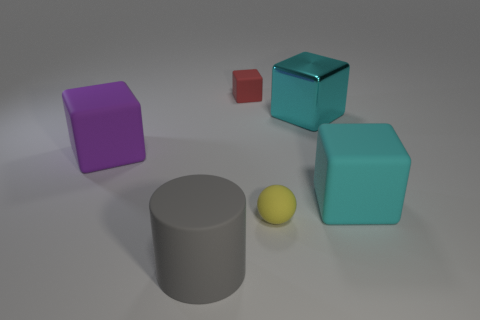Subtract 1 cubes. How many cubes are left? 3 Add 2 big red matte cubes. How many objects exist? 8 Subtract all balls. How many objects are left? 5 Add 2 red blocks. How many red blocks exist? 3 Subtract 1 purple blocks. How many objects are left? 5 Subtract all large purple cubes. Subtract all gray cylinders. How many objects are left? 4 Add 4 tiny red objects. How many tiny red objects are left? 5 